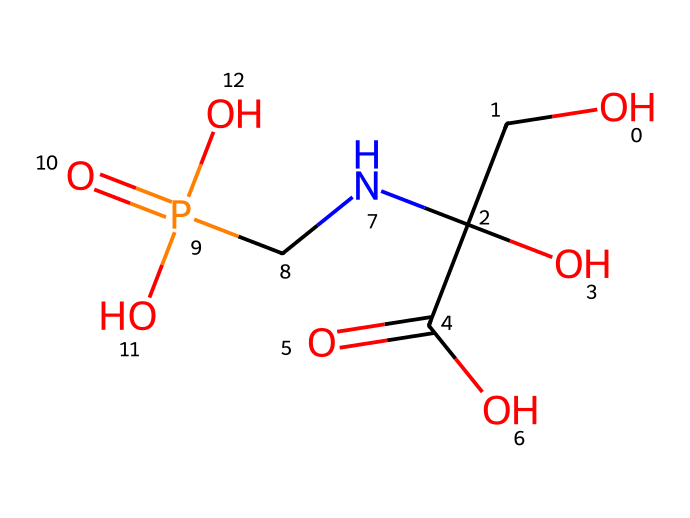What is the molecular formula of glyphosate? To determine the molecular formula, we count the number of each type of atom in the given SMILES representation. The structure contains carbon (C), hydrogen (H), oxygen (O), and nitrogen (N). Upon counting, we find there are 3 carbons, 6 hydrogens, 1 nitrogen, and 4 oxygens, leading to the molecular formula C3H8N5O4.
Answer: C3H8N5O4 How many functional groups are present in glyphosate? By analyzing the structure, we identify multiple functional groups: there’s a carboxylic acid (-COOH), an amine (-NH), and a phosphonic acid (-PO3H2). In total, there are three distinct functional groups present.
Answer: 3 What type of herbicide is glyphosate classified as? Glyphosate is classified as a non-selective herbicide, meaning it targets a wide range of plants indiscriminately. This can be verified from its structure and known usage in agriculture.
Answer: non-selective How many oxygen atoms are present in the glyphosate molecule? Referring to the SMILES representation, we can count the oxygen symbols ‘O’ which appear four times in total. Thus, the molecule contains four oxygen atoms.
Answer: 4 What role does the phosphonic acid group play in glyphosate's effectiveness? The phosphonic acid group in glyphosate enhances its systemic action, allowing it to be absorbed and translocated throughout the plant. This feature is crucial for its effectiveness as a herbicide.
Answer: systemic action Which part of the chemical structure makes glyphosate look similar to amino acids? Glyphosate has a structure that includes an amino group (-NH) and a carbon skeleton resembling that of certain amino acids, particularly glycine. This similarity is significant for its mechanism of action in plants.
Answer: amino group and carbon skeleton What is the impact of the carboxylic acid group in glyphosate? The carboxylic acid group contributes to glyphosate's solubility in water, which enhances its effectiveness in agricultural applications by improving absorption in soil and plants.
Answer: solubility in water 